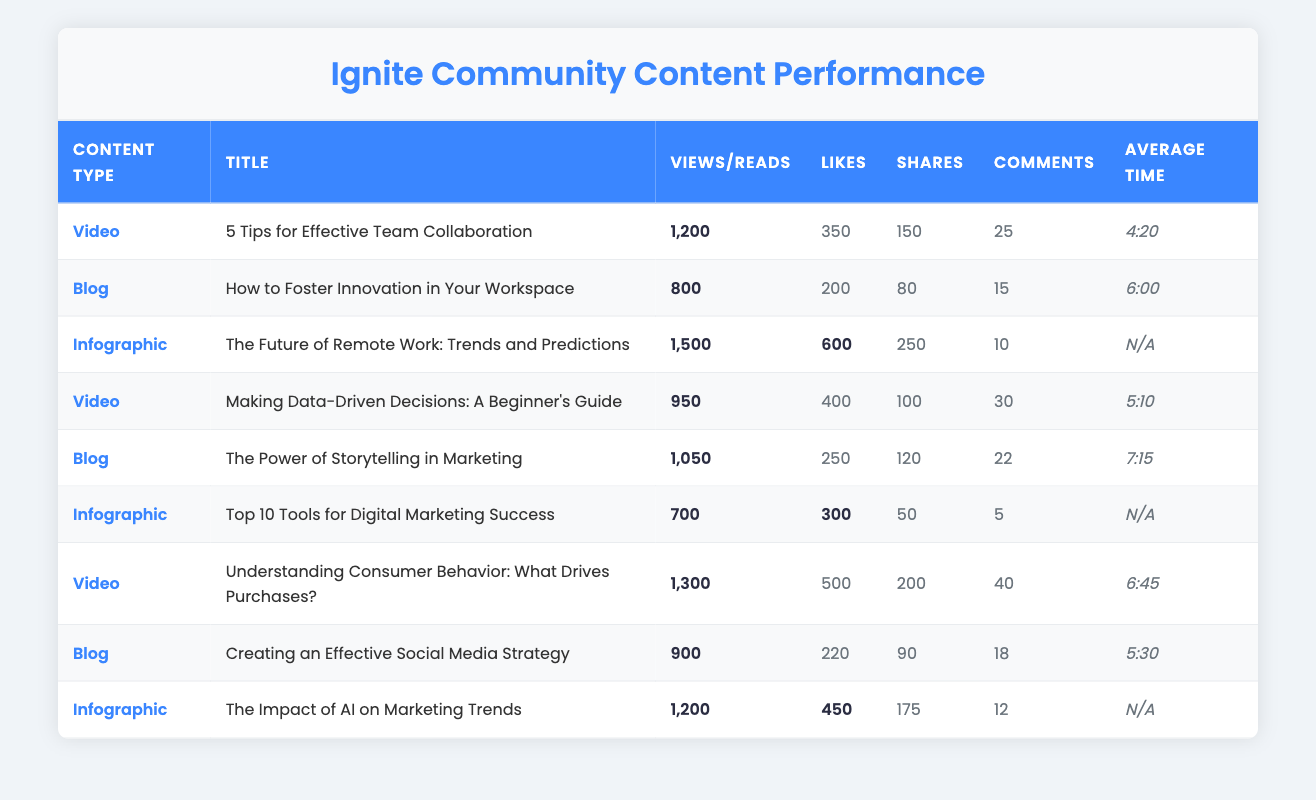What is the title of the video with the highest views? The video with the highest views is "Understanding Consumer Behavior: What Drives Purchases?" as it has 1,300 views, which is more than any other video listed in the table.
Answer: Understanding Consumer Behavior: What Drives Purchases? How many likes did the blog "The Power of Storytelling in Marketing" receive? The blog titled "The Power of Storytelling in Marketing" received 250 likes, as indicated in the corresponding row of the table.
Answer: 250 What is the average watch time for videos? To calculate the average watch time, we sum the watch times of the videos: 4:20 (260 seconds), 5:10 (310 seconds), and 6:45 (405 seconds). This gives us 260 + 310 + 405 = 975 seconds. There are 3 videos, so the average watch time is 975/3 = 325 seconds, which converts to 5:25.
Answer: 5:25 Did the infographic titled "Top 10 Tools for Digital Marketing Success" receive more downloads than likes? The infographic "Top 10 Tools for Digital Marketing Success" has 300 downloads and 0 likes (not listed), indicating that it has more downloads than likes.
Answer: Yes How many total comments did all the blog posts receive? To find the total comments from all blog posts, we take the comments for each blog: 15 (How to Foster Innovation in Your Workspace), 22 (The Power of Storytelling in Marketing), and 18 (Creating an Effective Social Media Strategy). Adding these gives us 15 + 22 + 18 = 55 total comments from the blogs.
Answer: 55 